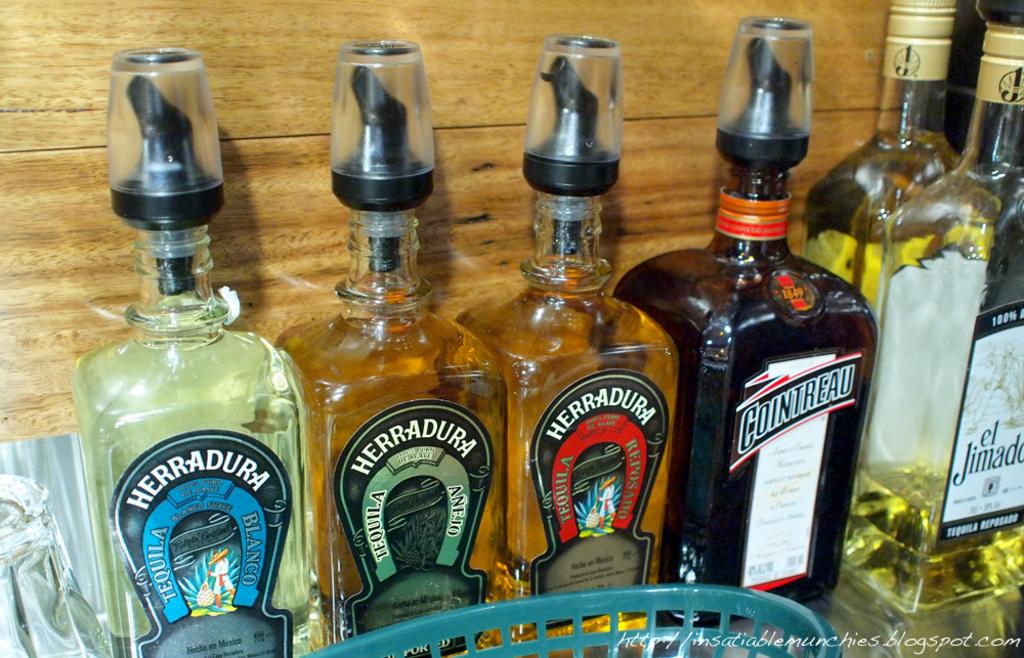Is the tequila all the way to the left a blanco?
Give a very brief answer. Yes. 